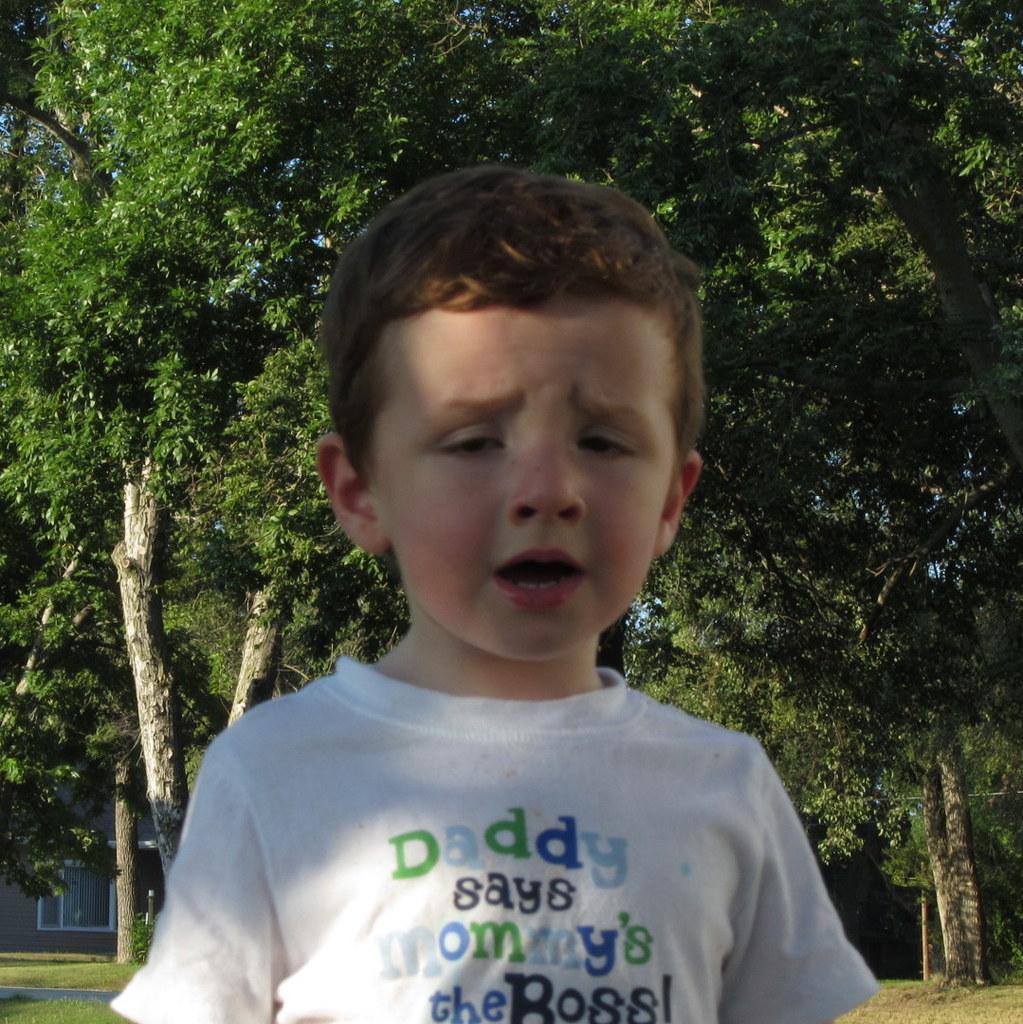In one or two sentences, can you explain what this image depicts? In the foreground I can see a boy on the grass. In the background I can see trees and a house. This image is taken may be in a park. 